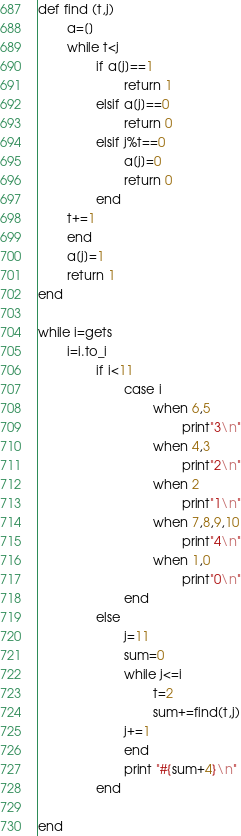Convert code to text. <code><loc_0><loc_0><loc_500><loc_500><_Ruby_>def find (t,j)
        a=[]
        while t<j
                if a[j]==1
                        return 1
                elsif a[j]==0
                        return 0
                elsif j%t==0
                        a[j]=0
                        return 0
                end
        t+=1
        end
        a[j]=1
        return 1
end

while i=gets
        i=i.to_i
                if i<11
                        case i
                                when 6,5
                                        print"3\n"
                                when 4,3
                                        print"2\n"
                                when 2
                                        print"1\n"
                                when 7,8,9,10
                                        print"4\n"
                                when 1,0
                                        print"0\n"
                        end
                else
                        j=11
                        sum=0
                        while j<=i
                                t=2
                                sum+=find(t,j)
                        j+=1
                        end
                        print "#{sum+4}\n"
                end

end</code> 